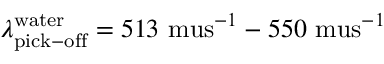<formula> <loc_0><loc_0><loc_500><loc_500>\lambda _ { p i c k - o f f } ^ { w a t e r } = 5 1 3 \ m u s ^ { - 1 } - 5 5 0 \ m u s ^ { - 1 }</formula> 